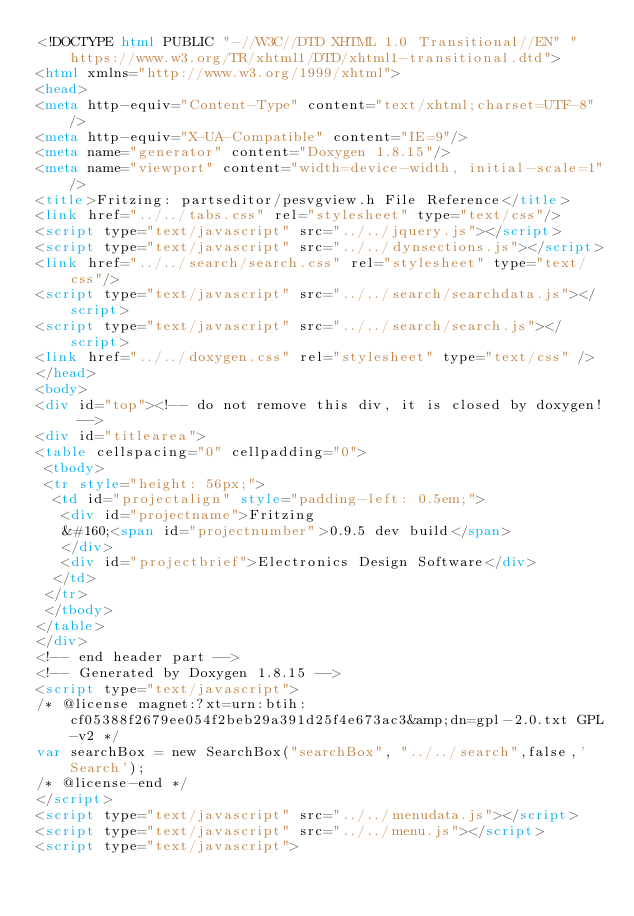Convert code to text. <code><loc_0><loc_0><loc_500><loc_500><_HTML_><!DOCTYPE html PUBLIC "-//W3C//DTD XHTML 1.0 Transitional//EN" "https://www.w3.org/TR/xhtml1/DTD/xhtml1-transitional.dtd">
<html xmlns="http://www.w3.org/1999/xhtml">
<head>
<meta http-equiv="Content-Type" content="text/xhtml;charset=UTF-8"/>
<meta http-equiv="X-UA-Compatible" content="IE=9"/>
<meta name="generator" content="Doxygen 1.8.15"/>
<meta name="viewport" content="width=device-width, initial-scale=1"/>
<title>Fritzing: partseditor/pesvgview.h File Reference</title>
<link href="../../tabs.css" rel="stylesheet" type="text/css"/>
<script type="text/javascript" src="../../jquery.js"></script>
<script type="text/javascript" src="../../dynsections.js"></script>
<link href="../../search/search.css" rel="stylesheet" type="text/css"/>
<script type="text/javascript" src="../../search/searchdata.js"></script>
<script type="text/javascript" src="../../search/search.js"></script>
<link href="../../doxygen.css" rel="stylesheet" type="text/css" />
</head>
<body>
<div id="top"><!-- do not remove this div, it is closed by doxygen! -->
<div id="titlearea">
<table cellspacing="0" cellpadding="0">
 <tbody>
 <tr style="height: 56px;">
  <td id="projectalign" style="padding-left: 0.5em;">
   <div id="projectname">Fritzing
   &#160;<span id="projectnumber">0.9.5 dev build</span>
   </div>
   <div id="projectbrief">Electronics Design Software</div>
  </td>
 </tr>
 </tbody>
</table>
</div>
<!-- end header part -->
<!-- Generated by Doxygen 1.8.15 -->
<script type="text/javascript">
/* @license magnet:?xt=urn:btih:cf05388f2679ee054f2beb29a391d25f4e673ac3&amp;dn=gpl-2.0.txt GPL-v2 */
var searchBox = new SearchBox("searchBox", "../../search",false,'Search');
/* @license-end */
</script>
<script type="text/javascript" src="../../menudata.js"></script>
<script type="text/javascript" src="../../menu.js"></script>
<script type="text/javascript"></code> 